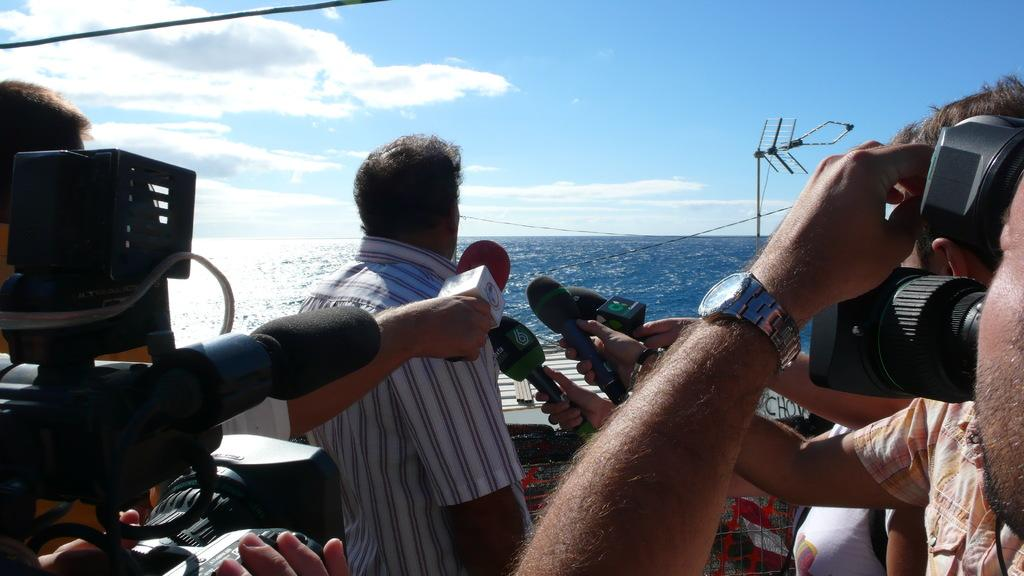What are the people in the image doing? Some of the people in the image are holding cameras, while others are holding mics. What can be seen in the background of the image? There is water, objects, and clouds in the sky visible in the background of the image. How many sisters are standing next to the station in the image? There is no station or sisters present in the image. 